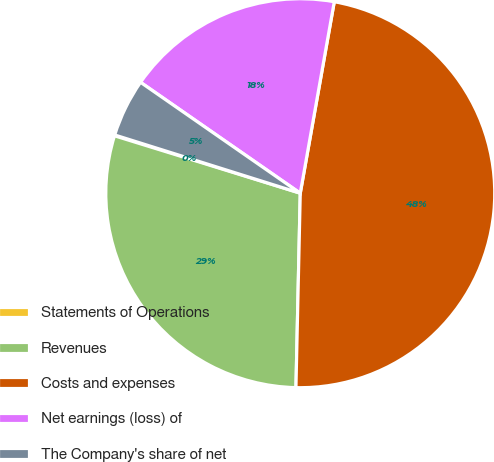<chart> <loc_0><loc_0><loc_500><loc_500><pie_chart><fcel>Statements of Operations<fcel>Revenues<fcel>Costs and expenses<fcel>Net earnings (loss) of<fcel>The Company's share of net<nl><fcel>0.07%<fcel>29.42%<fcel>47.56%<fcel>18.14%<fcel>4.82%<nl></chart> 